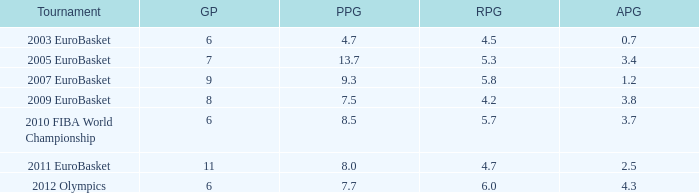How many assists per game in the tournament 2010 fiba world championship? 3.7. 